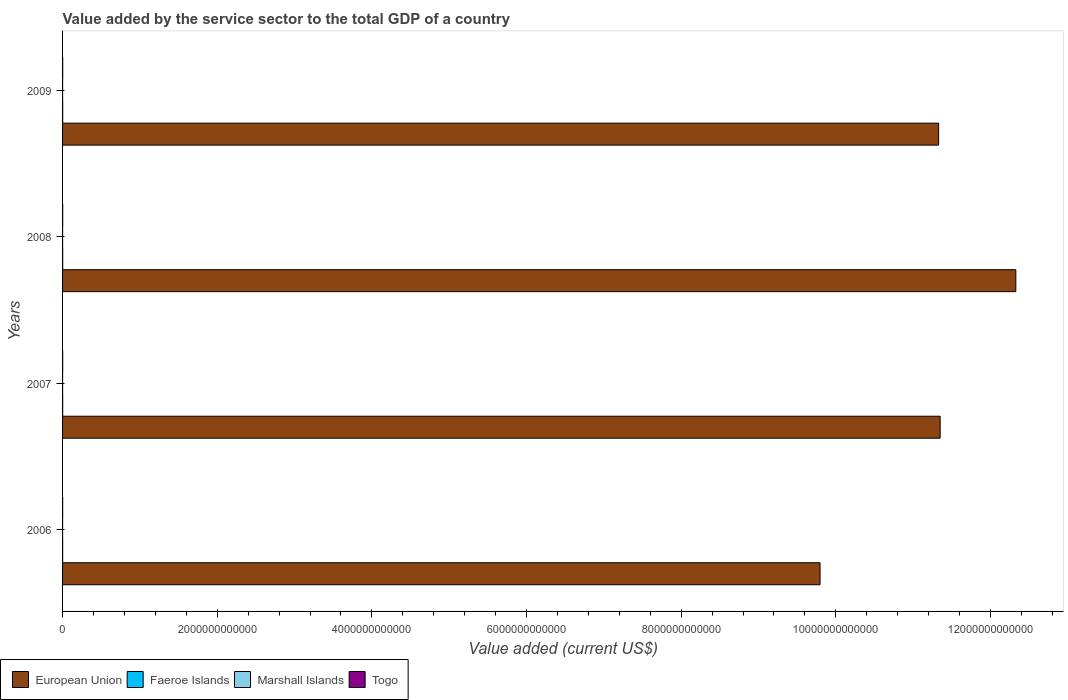How many groups of bars are there?
Offer a very short reply. 4. Are the number of bars per tick equal to the number of legend labels?
Make the answer very short. Yes. Are the number of bars on each tick of the Y-axis equal?
Your response must be concise. Yes. In how many cases, is the number of bars for a given year not equal to the number of legend labels?
Give a very brief answer. 0. What is the value added by the service sector to the total GDP in Marshall Islands in 2007?
Keep it short and to the point. 1.07e+08. Across all years, what is the maximum value added by the service sector to the total GDP in Marshall Islands?
Provide a succinct answer. 1.09e+08. Across all years, what is the minimum value added by the service sector to the total GDP in Togo?
Provide a succinct answer. 1.01e+09. What is the total value added by the service sector to the total GDP in Togo in the graph?
Offer a terse response. 5.07e+09. What is the difference between the value added by the service sector to the total GDP in Marshall Islands in 2006 and that in 2009?
Offer a terse response. -5.97e+06. What is the difference between the value added by the service sector to the total GDP in Marshall Islands in 2006 and the value added by the service sector to the total GDP in European Union in 2008?
Provide a succinct answer. -1.23e+13. What is the average value added by the service sector to the total GDP in Marshall Islands per year?
Provide a short and direct response. 1.06e+08. In the year 2007, what is the difference between the value added by the service sector to the total GDP in Togo and value added by the service sector to the total GDP in European Union?
Provide a short and direct response. -1.13e+13. What is the ratio of the value added by the service sector to the total GDP in European Union in 2008 to that in 2009?
Your answer should be very brief. 1.09. Is the value added by the service sector to the total GDP in Togo in 2007 less than that in 2009?
Offer a very short reply. Yes. What is the difference between the highest and the second highest value added by the service sector to the total GDP in European Union?
Offer a terse response. 9.79e+11. What is the difference between the highest and the lowest value added by the service sector to the total GDP in Faeroe Islands?
Provide a short and direct response. 3.42e+08. In how many years, is the value added by the service sector to the total GDP in European Union greater than the average value added by the service sector to the total GDP in European Union taken over all years?
Your response must be concise. 3. What does the 3rd bar from the bottom in 2007 represents?
Offer a terse response. Marshall Islands. Is it the case that in every year, the sum of the value added by the service sector to the total GDP in European Union and value added by the service sector to the total GDP in Marshall Islands is greater than the value added by the service sector to the total GDP in Togo?
Your answer should be compact. Yes. What is the difference between two consecutive major ticks on the X-axis?
Make the answer very short. 2.00e+12. Are the values on the major ticks of X-axis written in scientific E-notation?
Ensure brevity in your answer.  No. Does the graph contain grids?
Your response must be concise. No. How are the legend labels stacked?
Provide a short and direct response. Horizontal. What is the title of the graph?
Offer a very short reply. Value added by the service sector to the total GDP of a country. Does "Russian Federation" appear as one of the legend labels in the graph?
Give a very brief answer. No. What is the label or title of the X-axis?
Keep it short and to the point. Value added (current US$). What is the label or title of the Y-axis?
Your answer should be compact. Years. What is the Value added (current US$) in European Union in 2006?
Ensure brevity in your answer.  9.80e+12. What is the Value added (current US$) in Faeroe Islands in 2006?
Make the answer very short. 1.06e+09. What is the Value added (current US$) in Marshall Islands in 2006?
Your response must be concise. 1.03e+08. What is the Value added (current US$) in Togo in 2006?
Offer a very short reply. 1.01e+09. What is the Value added (current US$) of European Union in 2007?
Provide a short and direct response. 1.13e+13. What is the Value added (current US$) in Faeroe Islands in 2007?
Your response must be concise. 1.25e+09. What is the Value added (current US$) of Marshall Islands in 2007?
Offer a terse response. 1.07e+08. What is the Value added (current US$) of Togo in 2007?
Offer a very short reply. 1.15e+09. What is the Value added (current US$) in European Union in 2008?
Give a very brief answer. 1.23e+13. What is the Value added (current US$) in Faeroe Islands in 2008?
Keep it short and to the point. 1.40e+09. What is the Value added (current US$) in Marshall Islands in 2008?
Ensure brevity in your answer.  1.07e+08. What is the Value added (current US$) of Togo in 2008?
Keep it short and to the point. 1.30e+09. What is the Value added (current US$) of European Union in 2009?
Keep it short and to the point. 1.13e+13. What is the Value added (current US$) in Faeroe Islands in 2009?
Your answer should be very brief. 1.36e+09. What is the Value added (current US$) of Marshall Islands in 2009?
Your response must be concise. 1.09e+08. What is the Value added (current US$) in Togo in 2009?
Offer a terse response. 1.62e+09. Across all years, what is the maximum Value added (current US$) in European Union?
Offer a terse response. 1.23e+13. Across all years, what is the maximum Value added (current US$) in Faeroe Islands?
Make the answer very short. 1.40e+09. Across all years, what is the maximum Value added (current US$) in Marshall Islands?
Keep it short and to the point. 1.09e+08. Across all years, what is the maximum Value added (current US$) of Togo?
Your answer should be compact. 1.62e+09. Across all years, what is the minimum Value added (current US$) in European Union?
Provide a short and direct response. 9.80e+12. Across all years, what is the minimum Value added (current US$) in Faeroe Islands?
Provide a short and direct response. 1.06e+09. Across all years, what is the minimum Value added (current US$) of Marshall Islands?
Ensure brevity in your answer.  1.03e+08. Across all years, what is the minimum Value added (current US$) of Togo?
Ensure brevity in your answer.  1.01e+09. What is the total Value added (current US$) in European Union in the graph?
Offer a very short reply. 4.48e+13. What is the total Value added (current US$) of Faeroe Islands in the graph?
Ensure brevity in your answer.  5.07e+09. What is the total Value added (current US$) in Marshall Islands in the graph?
Your answer should be very brief. 4.25e+08. What is the total Value added (current US$) of Togo in the graph?
Make the answer very short. 5.07e+09. What is the difference between the Value added (current US$) in European Union in 2006 and that in 2007?
Your response must be concise. -1.55e+12. What is the difference between the Value added (current US$) of Faeroe Islands in 2006 and that in 2007?
Keep it short and to the point. -1.92e+08. What is the difference between the Value added (current US$) in Marshall Islands in 2006 and that in 2007?
Make the answer very short. -4.31e+06. What is the difference between the Value added (current US$) of Togo in 2006 and that in 2007?
Keep it short and to the point. -1.41e+08. What is the difference between the Value added (current US$) of European Union in 2006 and that in 2008?
Offer a very short reply. -2.53e+12. What is the difference between the Value added (current US$) in Faeroe Islands in 2006 and that in 2008?
Your response must be concise. -3.42e+08. What is the difference between the Value added (current US$) of Marshall Islands in 2006 and that in 2008?
Keep it short and to the point. -3.88e+06. What is the difference between the Value added (current US$) of Togo in 2006 and that in 2008?
Your answer should be compact. -2.94e+08. What is the difference between the Value added (current US$) of European Union in 2006 and that in 2009?
Ensure brevity in your answer.  -1.53e+12. What is the difference between the Value added (current US$) in Faeroe Islands in 2006 and that in 2009?
Provide a succinct answer. -3.05e+08. What is the difference between the Value added (current US$) in Marshall Islands in 2006 and that in 2009?
Offer a terse response. -5.97e+06. What is the difference between the Value added (current US$) in Togo in 2006 and that in 2009?
Provide a short and direct response. -6.10e+08. What is the difference between the Value added (current US$) in European Union in 2007 and that in 2008?
Your response must be concise. -9.79e+11. What is the difference between the Value added (current US$) of Faeroe Islands in 2007 and that in 2008?
Your answer should be very brief. -1.50e+08. What is the difference between the Value added (current US$) in Marshall Islands in 2007 and that in 2008?
Your answer should be compact. 4.35e+05. What is the difference between the Value added (current US$) in Togo in 2007 and that in 2008?
Give a very brief answer. -1.53e+08. What is the difference between the Value added (current US$) of European Union in 2007 and that in 2009?
Make the answer very short. 1.98e+1. What is the difference between the Value added (current US$) of Faeroe Islands in 2007 and that in 2009?
Provide a succinct answer. -1.13e+08. What is the difference between the Value added (current US$) of Marshall Islands in 2007 and that in 2009?
Your answer should be compact. -1.65e+06. What is the difference between the Value added (current US$) in Togo in 2007 and that in 2009?
Your answer should be very brief. -4.69e+08. What is the difference between the Value added (current US$) of European Union in 2008 and that in 2009?
Make the answer very short. 9.98e+11. What is the difference between the Value added (current US$) of Faeroe Islands in 2008 and that in 2009?
Ensure brevity in your answer.  3.71e+07. What is the difference between the Value added (current US$) in Marshall Islands in 2008 and that in 2009?
Keep it short and to the point. -2.09e+06. What is the difference between the Value added (current US$) in Togo in 2008 and that in 2009?
Keep it short and to the point. -3.16e+08. What is the difference between the Value added (current US$) of European Union in 2006 and the Value added (current US$) of Faeroe Islands in 2007?
Provide a short and direct response. 9.79e+12. What is the difference between the Value added (current US$) of European Union in 2006 and the Value added (current US$) of Marshall Islands in 2007?
Provide a succinct answer. 9.80e+12. What is the difference between the Value added (current US$) of European Union in 2006 and the Value added (current US$) of Togo in 2007?
Give a very brief answer. 9.79e+12. What is the difference between the Value added (current US$) of Faeroe Islands in 2006 and the Value added (current US$) of Marshall Islands in 2007?
Offer a terse response. 9.51e+08. What is the difference between the Value added (current US$) of Faeroe Islands in 2006 and the Value added (current US$) of Togo in 2007?
Provide a succinct answer. -8.98e+07. What is the difference between the Value added (current US$) in Marshall Islands in 2006 and the Value added (current US$) in Togo in 2007?
Keep it short and to the point. -1.05e+09. What is the difference between the Value added (current US$) of European Union in 2006 and the Value added (current US$) of Faeroe Islands in 2008?
Make the answer very short. 9.79e+12. What is the difference between the Value added (current US$) of European Union in 2006 and the Value added (current US$) of Marshall Islands in 2008?
Ensure brevity in your answer.  9.80e+12. What is the difference between the Value added (current US$) of European Union in 2006 and the Value added (current US$) of Togo in 2008?
Your answer should be compact. 9.79e+12. What is the difference between the Value added (current US$) in Faeroe Islands in 2006 and the Value added (current US$) in Marshall Islands in 2008?
Offer a terse response. 9.51e+08. What is the difference between the Value added (current US$) in Faeroe Islands in 2006 and the Value added (current US$) in Togo in 2008?
Offer a terse response. -2.43e+08. What is the difference between the Value added (current US$) of Marshall Islands in 2006 and the Value added (current US$) of Togo in 2008?
Your response must be concise. -1.20e+09. What is the difference between the Value added (current US$) in European Union in 2006 and the Value added (current US$) in Faeroe Islands in 2009?
Your response must be concise. 9.79e+12. What is the difference between the Value added (current US$) of European Union in 2006 and the Value added (current US$) of Marshall Islands in 2009?
Offer a terse response. 9.80e+12. What is the difference between the Value added (current US$) in European Union in 2006 and the Value added (current US$) in Togo in 2009?
Offer a very short reply. 9.79e+12. What is the difference between the Value added (current US$) in Faeroe Islands in 2006 and the Value added (current US$) in Marshall Islands in 2009?
Offer a terse response. 9.49e+08. What is the difference between the Value added (current US$) in Faeroe Islands in 2006 and the Value added (current US$) in Togo in 2009?
Offer a terse response. -5.58e+08. What is the difference between the Value added (current US$) in Marshall Islands in 2006 and the Value added (current US$) in Togo in 2009?
Your response must be concise. -1.51e+09. What is the difference between the Value added (current US$) in European Union in 2007 and the Value added (current US$) in Faeroe Islands in 2008?
Offer a terse response. 1.13e+13. What is the difference between the Value added (current US$) of European Union in 2007 and the Value added (current US$) of Marshall Islands in 2008?
Your answer should be very brief. 1.13e+13. What is the difference between the Value added (current US$) of European Union in 2007 and the Value added (current US$) of Togo in 2008?
Your answer should be very brief. 1.13e+13. What is the difference between the Value added (current US$) of Faeroe Islands in 2007 and the Value added (current US$) of Marshall Islands in 2008?
Your response must be concise. 1.14e+09. What is the difference between the Value added (current US$) in Faeroe Islands in 2007 and the Value added (current US$) in Togo in 2008?
Provide a succinct answer. -5.10e+07. What is the difference between the Value added (current US$) in Marshall Islands in 2007 and the Value added (current US$) in Togo in 2008?
Offer a very short reply. -1.19e+09. What is the difference between the Value added (current US$) of European Union in 2007 and the Value added (current US$) of Faeroe Islands in 2009?
Make the answer very short. 1.13e+13. What is the difference between the Value added (current US$) in European Union in 2007 and the Value added (current US$) in Marshall Islands in 2009?
Your response must be concise. 1.13e+13. What is the difference between the Value added (current US$) of European Union in 2007 and the Value added (current US$) of Togo in 2009?
Ensure brevity in your answer.  1.13e+13. What is the difference between the Value added (current US$) in Faeroe Islands in 2007 and the Value added (current US$) in Marshall Islands in 2009?
Give a very brief answer. 1.14e+09. What is the difference between the Value added (current US$) of Faeroe Islands in 2007 and the Value added (current US$) of Togo in 2009?
Ensure brevity in your answer.  -3.67e+08. What is the difference between the Value added (current US$) of Marshall Islands in 2007 and the Value added (current US$) of Togo in 2009?
Provide a short and direct response. -1.51e+09. What is the difference between the Value added (current US$) of European Union in 2008 and the Value added (current US$) of Faeroe Islands in 2009?
Your answer should be very brief. 1.23e+13. What is the difference between the Value added (current US$) in European Union in 2008 and the Value added (current US$) in Marshall Islands in 2009?
Give a very brief answer. 1.23e+13. What is the difference between the Value added (current US$) in European Union in 2008 and the Value added (current US$) in Togo in 2009?
Your answer should be very brief. 1.23e+13. What is the difference between the Value added (current US$) of Faeroe Islands in 2008 and the Value added (current US$) of Marshall Islands in 2009?
Offer a terse response. 1.29e+09. What is the difference between the Value added (current US$) in Faeroe Islands in 2008 and the Value added (current US$) in Togo in 2009?
Provide a succinct answer. -2.17e+08. What is the difference between the Value added (current US$) of Marshall Islands in 2008 and the Value added (current US$) of Togo in 2009?
Ensure brevity in your answer.  -1.51e+09. What is the average Value added (current US$) of European Union per year?
Provide a succinct answer. 1.12e+13. What is the average Value added (current US$) in Faeroe Islands per year?
Ensure brevity in your answer.  1.27e+09. What is the average Value added (current US$) in Marshall Islands per year?
Your response must be concise. 1.06e+08. What is the average Value added (current US$) of Togo per year?
Give a very brief answer. 1.27e+09. In the year 2006, what is the difference between the Value added (current US$) of European Union and Value added (current US$) of Faeroe Islands?
Ensure brevity in your answer.  9.79e+12. In the year 2006, what is the difference between the Value added (current US$) of European Union and Value added (current US$) of Marshall Islands?
Ensure brevity in your answer.  9.80e+12. In the year 2006, what is the difference between the Value added (current US$) in European Union and Value added (current US$) in Togo?
Your answer should be very brief. 9.79e+12. In the year 2006, what is the difference between the Value added (current US$) of Faeroe Islands and Value added (current US$) of Marshall Islands?
Your response must be concise. 9.55e+08. In the year 2006, what is the difference between the Value added (current US$) of Faeroe Islands and Value added (current US$) of Togo?
Make the answer very short. 5.15e+07. In the year 2006, what is the difference between the Value added (current US$) in Marshall Islands and Value added (current US$) in Togo?
Make the answer very short. -9.04e+08. In the year 2007, what is the difference between the Value added (current US$) in European Union and Value added (current US$) in Faeroe Islands?
Your answer should be compact. 1.13e+13. In the year 2007, what is the difference between the Value added (current US$) in European Union and Value added (current US$) in Marshall Islands?
Make the answer very short. 1.13e+13. In the year 2007, what is the difference between the Value added (current US$) in European Union and Value added (current US$) in Togo?
Provide a short and direct response. 1.13e+13. In the year 2007, what is the difference between the Value added (current US$) of Faeroe Islands and Value added (current US$) of Marshall Islands?
Your answer should be compact. 1.14e+09. In the year 2007, what is the difference between the Value added (current US$) of Faeroe Islands and Value added (current US$) of Togo?
Ensure brevity in your answer.  1.02e+08. In the year 2007, what is the difference between the Value added (current US$) of Marshall Islands and Value added (current US$) of Togo?
Provide a succinct answer. -1.04e+09. In the year 2008, what is the difference between the Value added (current US$) in European Union and Value added (current US$) in Faeroe Islands?
Provide a short and direct response. 1.23e+13. In the year 2008, what is the difference between the Value added (current US$) of European Union and Value added (current US$) of Marshall Islands?
Make the answer very short. 1.23e+13. In the year 2008, what is the difference between the Value added (current US$) in European Union and Value added (current US$) in Togo?
Make the answer very short. 1.23e+13. In the year 2008, what is the difference between the Value added (current US$) of Faeroe Islands and Value added (current US$) of Marshall Islands?
Provide a short and direct response. 1.29e+09. In the year 2008, what is the difference between the Value added (current US$) in Faeroe Islands and Value added (current US$) in Togo?
Keep it short and to the point. 9.90e+07. In the year 2008, what is the difference between the Value added (current US$) in Marshall Islands and Value added (current US$) in Togo?
Ensure brevity in your answer.  -1.19e+09. In the year 2009, what is the difference between the Value added (current US$) of European Union and Value added (current US$) of Faeroe Islands?
Give a very brief answer. 1.13e+13. In the year 2009, what is the difference between the Value added (current US$) in European Union and Value added (current US$) in Marshall Islands?
Ensure brevity in your answer.  1.13e+13. In the year 2009, what is the difference between the Value added (current US$) in European Union and Value added (current US$) in Togo?
Your response must be concise. 1.13e+13. In the year 2009, what is the difference between the Value added (current US$) of Faeroe Islands and Value added (current US$) of Marshall Islands?
Ensure brevity in your answer.  1.25e+09. In the year 2009, what is the difference between the Value added (current US$) of Faeroe Islands and Value added (current US$) of Togo?
Your response must be concise. -2.54e+08. In the year 2009, what is the difference between the Value added (current US$) of Marshall Islands and Value added (current US$) of Togo?
Offer a terse response. -1.51e+09. What is the ratio of the Value added (current US$) in European Union in 2006 to that in 2007?
Provide a short and direct response. 0.86. What is the ratio of the Value added (current US$) in Faeroe Islands in 2006 to that in 2007?
Keep it short and to the point. 0.85. What is the ratio of the Value added (current US$) of Marshall Islands in 2006 to that in 2007?
Your answer should be compact. 0.96. What is the ratio of the Value added (current US$) in Togo in 2006 to that in 2007?
Offer a terse response. 0.88. What is the ratio of the Value added (current US$) of European Union in 2006 to that in 2008?
Offer a very short reply. 0.79. What is the ratio of the Value added (current US$) of Faeroe Islands in 2006 to that in 2008?
Ensure brevity in your answer.  0.76. What is the ratio of the Value added (current US$) in Marshall Islands in 2006 to that in 2008?
Ensure brevity in your answer.  0.96. What is the ratio of the Value added (current US$) in Togo in 2006 to that in 2008?
Provide a short and direct response. 0.77. What is the ratio of the Value added (current US$) of European Union in 2006 to that in 2009?
Ensure brevity in your answer.  0.86. What is the ratio of the Value added (current US$) in Faeroe Islands in 2006 to that in 2009?
Ensure brevity in your answer.  0.78. What is the ratio of the Value added (current US$) in Marshall Islands in 2006 to that in 2009?
Provide a succinct answer. 0.95. What is the ratio of the Value added (current US$) of Togo in 2006 to that in 2009?
Provide a short and direct response. 0.62. What is the ratio of the Value added (current US$) in European Union in 2007 to that in 2008?
Offer a terse response. 0.92. What is the ratio of the Value added (current US$) of Faeroe Islands in 2007 to that in 2008?
Offer a very short reply. 0.89. What is the ratio of the Value added (current US$) in Togo in 2007 to that in 2008?
Your response must be concise. 0.88. What is the ratio of the Value added (current US$) of Faeroe Islands in 2007 to that in 2009?
Offer a very short reply. 0.92. What is the ratio of the Value added (current US$) of Marshall Islands in 2007 to that in 2009?
Keep it short and to the point. 0.98. What is the ratio of the Value added (current US$) of Togo in 2007 to that in 2009?
Keep it short and to the point. 0.71. What is the ratio of the Value added (current US$) in European Union in 2008 to that in 2009?
Your response must be concise. 1.09. What is the ratio of the Value added (current US$) in Faeroe Islands in 2008 to that in 2009?
Give a very brief answer. 1.03. What is the ratio of the Value added (current US$) in Marshall Islands in 2008 to that in 2009?
Your answer should be compact. 0.98. What is the ratio of the Value added (current US$) in Togo in 2008 to that in 2009?
Keep it short and to the point. 0.8. What is the difference between the highest and the second highest Value added (current US$) of European Union?
Provide a short and direct response. 9.79e+11. What is the difference between the highest and the second highest Value added (current US$) in Faeroe Islands?
Your response must be concise. 3.71e+07. What is the difference between the highest and the second highest Value added (current US$) in Marshall Islands?
Offer a very short reply. 1.65e+06. What is the difference between the highest and the second highest Value added (current US$) in Togo?
Provide a succinct answer. 3.16e+08. What is the difference between the highest and the lowest Value added (current US$) of European Union?
Keep it short and to the point. 2.53e+12. What is the difference between the highest and the lowest Value added (current US$) of Faeroe Islands?
Provide a short and direct response. 3.42e+08. What is the difference between the highest and the lowest Value added (current US$) in Marshall Islands?
Ensure brevity in your answer.  5.97e+06. What is the difference between the highest and the lowest Value added (current US$) of Togo?
Offer a terse response. 6.10e+08. 